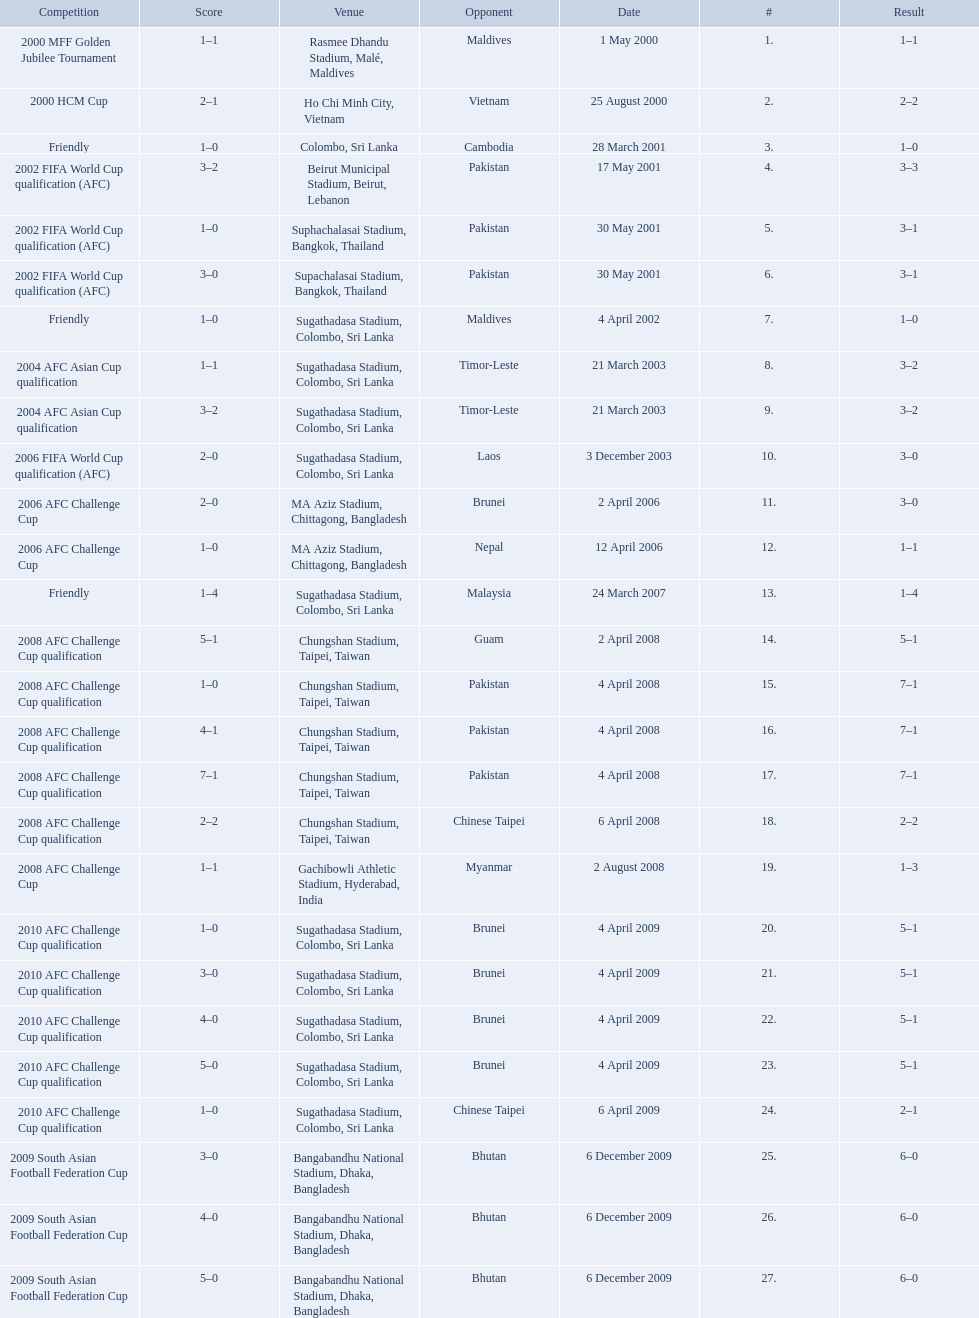What venues are listed? Rasmee Dhandu Stadium, Malé, Maldives, Ho Chi Minh City, Vietnam, Colombo, Sri Lanka, Beirut Municipal Stadium, Beirut, Lebanon, Suphachalasai Stadium, Bangkok, Thailand, MA Aziz Stadium, Chittagong, Bangladesh, Sugathadasa Stadium, Colombo, Sri Lanka, Chungshan Stadium, Taipei, Taiwan, Gachibowli Athletic Stadium, Hyderabad, India, Sugathadasa Stadium, Colombo, Sri Lanka, Bangabandhu National Stadium, Dhaka, Bangladesh. Which is top listed? Rasmee Dhandu Stadium, Malé, Maldives. 